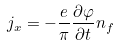Convert formula to latex. <formula><loc_0><loc_0><loc_500><loc_500>j _ { x } = - \frac { e } { \pi } \frac { \partial \varphi } { \partial t } n _ { f } \\</formula> 